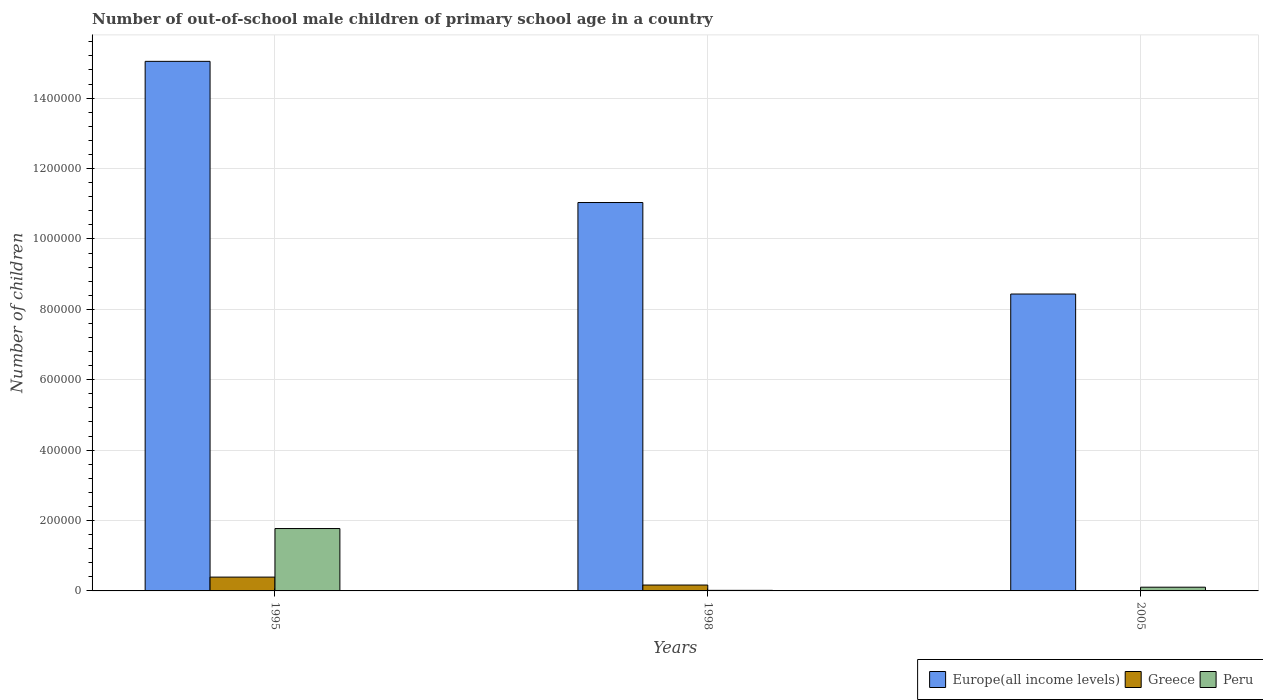How many groups of bars are there?
Give a very brief answer. 3. Are the number of bars per tick equal to the number of legend labels?
Your answer should be very brief. Yes. What is the label of the 2nd group of bars from the left?
Provide a short and direct response. 1998. In how many cases, is the number of bars for a given year not equal to the number of legend labels?
Your answer should be compact. 0. What is the number of out-of-school male children in Europe(all income levels) in 1995?
Make the answer very short. 1.50e+06. Across all years, what is the maximum number of out-of-school male children in Peru?
Keep it short and to the point. 1.77e+05. Across all years, what is the minimum number of out-of-school male children in Europe(all income levels)?
Give a very brief answer. 8.43e+05. What is the total number of out-of-school male children in Europe(all income levels) in the graph?
Your response must be concise. 3.45e+06. What is the difference between the number of out-of-school male children in Peru in 1998 and that in 2005?
Give a very brief answer. -8945. What is the difference between the number of out-of-school male children in Greece in 1998 and the number of out-of-school male children in Europe(all income levels) in 1995?
Ensure brevity in your answer.  -1.49e+06. What is the average number of out-of-school male children in Greece per year?
Keep it short and to the point. 1.87e+04. In the year 1998, what is the difference between the number of out-of-school male children in Peru and number of out-of-school male children in Europe(all income levels)?
Offer a very short reply. -1.10e+06. What is the ratio of the number of out-of-school male children in Peru in 1998 to that in 2005?
Keep it short and to the point. 0.15. What is the difference between the highest and the second highest number of out-of-school male children in Greece?
Provide a short and direct response. 2.25e+04. What is the difference between the highest and the lowest number of out-of-school male children in Greece?
Your answer should be very brief. 3.90e+04. Is the sum of the number of out-of-school male children in Europe(all income levels) in 1995 and 2005 greater than the maximum number of out-of-school male children in Greece across all years?
Provide a succinct answer. Yes. What does the 2nd bar from the left in 1998 represents?
Keep it short and to the point. Greece. What does the 1st bar from the right in 2005 represents?
Your answer should be compact. Peru. How many bars are there?
Your response must be concise. 9. Are the values on the major ticks of Y-axis written in scientific E-notation?
Offer a terse response. No. How many legend labels are there?
Your answer should be very brief. 3. How are the legend labels stacked?
Your response must be concise. Horizontal. What is the title of the graph?
Your answer should be compact. Number of out-of-school male children of primary school age in a country. What is the label or title of the X-axis?
Offer a very short reply. Years. What is the label or title of the Y-axis?
Provide a short and direct response. Number of children. What is the Number of children of Europe(all income levels) in 1995?
Ensure brevity in your answer.  1.50e+06. What is the Number of children of Greece in 1995?
Make the answer very short. 3.92e+04. What is the Number of children in Peru in 1995?
Provide a short and direct response. 1.77e+05. What is the Number of children of Europe(all income levels) in 1998?
Offer a very short reply. 1.10e+06. What is the Number of children in Greece in 1998?
Offer a terse response. 1.67e+04. What is the Number of children in Peru in 1998?
Offer a very short reply. 1620. What is the Number of children in Europe(all income levels) in 2005?
Your answer should be very brief. 8.43e+05. What is the Number of children in Greece in 2005?
Your answer should be compact. 241. What is the Number of children of Peru in 2005?
Your answer should be compact. 1.06e+04. Across all years, what is the maximum Number of children in Europe(all income levels)?
Your response must be concise. 1.50e+06. Across all years, what is the maximum Number of children of Greece?
Provide a succinct answer. 3.92e+04. Across all years, what is the maximum Number of children of Peru?
Offer a very short reply. 1.77e+05. Across all years, what is the minimum Number of children of Europe(all income levels)?
Keep it short and to the point. 8.43e+05. Across all years, what is the minimum Number of children of Greece?
Your answer should be very brief. 241. Across all years, what is the minimum Number of children in Peru?
Offer a very short reply. 1620. What is the total Number of children of Europe(all income levels) in the graph?
Your answer should be compact. 3.45e+06. What is the total Number of children of Greece in the graph?
Your answer should be very brief. 5.62e+04. What is the total Number of children of Peru in the graph?
Offer a terse response. 1.89e+05. What is the difference between the Number of children of Europe(all income levels) in 1995 and that in 1998?
Offer a very short reply. 4.01e+05. What is the difference between the Number of children in Greece in 1995 and that in 1998?
Offer a terse response. 2.25e+04. What is the difference between the Number of children in Peru in 1995 and that in 1998?
Your answer should be very brief. 1.76e+05. What is the difference between the Number of children of Europe(all income levels) in 1995 and that in 2005?
Keep it short and to the point. 6.61e+05. What is the difference between the Number of children in Greece in 1995 and that in 2005?
Your answer should be very brief. 3.90e+04. What is the difference between the Number of children of Peru in 1995 and that in 2005?
Make the answer very short. 1.67e+05. What is the difference between the Number of children of Europe(all income levels) in 1998 and that in 2005?
Your answer should be very brief. 2.60e+05. What is the difference between the Number of children of Greece in 1998 and that in 2005?
Ensure brevity in your answer.  1.65e+04. What is the difference between the Number of children in Peru in 1998 and that in 2005?
Offer a very short reply. -8945. What is the difference between the Number of children in Europe(all income levels) in 1995 and the Number of children in Greece in 1998?
Provide a succinct answer. 1.49e+06. What is the difference between the Number of children of Europe(all income levels) in 1995 and the Number of children of Peru in 1998?
Your answer should be very brief. 1.50e+06. What is the difference between the Number of children of Greece in 1995 and the Number of children of Peru in 1998?
Your answer should be very brief. 3.76e+04. What is the difference between the Number of children in Europe(all income levels) in 1995 and the Number of children in Greece in 2005?
Provide a succinct answer. 1.50e+06. What is the difference between the Number of children of Europe(all income levels) in 1995 and the Number of children of Peru in 2005?
Ensure brevity in your answer.  1.49e+06. What is the difference between the Number of children of Greece in 1995 and the Number of children of Peru in 2005?
Give a very brief answer. 2.87e+04. What is the difference between the Number of children of Europe(all income levels) in 1998 and the Number of children of Greece in 2005?
Provide a succinct answer. 1.10e+06. What is the difference between the Number of children in Europe(all income levels) in 1998 and the Number of children in Peru in 2005?
Your response must be concise. 1.09e+06. What is the difference between the Number of children in Greece in 1998 and the Number of children in Peru in 2005?
Offer a very short reply. 6163. What is the average Number of children of Europe(all income levels) per year?
Offer a terse response. 1.15e+06. What is the average Number of children of Greece per year?
Your answer should be compact. 1.87e+04. What is the average Number of children in Peru per year?
Provide a short and direct response. 6.31e+04. In the year 1995, what is the difference between the Number of children in Europe(all income levels) and Number of children in Greece?
Give a very brief answer. 1.47e+06. In the year 1995, what is the difference between the Number of children in Europe(all income levels) and Number of children in Peru?
Ensure brevity in your answer.  1.33e+06. In the year 1995, what is the difference between the Number of children of Greece and Number of children of Peru?
Provide a succinct answer. -1.38e+05. In the year 1998, what is the difference between the Number of children of Europe(all income levels) and Number of children of Greece?
Your answer should be compact. 1.09e+06. In the year 1998, what is the difference between the Number of children of Europe(all income levels) and Number of children of Peru?
Offer a terse response. 1.10e+06. In the year 1998, what is the difference between the Number of children of Greece and Number of children of Peru?
Offer a terse response. 1.51e+04. In the year 2005, what is the difference between the Number of children of Europe(all income levels) and Number of children of Greece?
Make the answer very short. 8.43e+05. In the year 2005, what is the difference between the Number of children in Europe(all income levels) and Number of children in Peru?
Ensure brevity in your answer.  8.33e+05. In the year 2005, what is the difference between the Number of children in Greece and Number of children in Peru?
Provide a succinct answer. -1.03e+04. What is the ratio of the Number of children in Europe(all income levels) in 1995 to that in 1998?
Provide a short and direct response. 1.36. What is the ratio of the Number of children of Greece in 1995 to that in 1998?
Your answer should be very brief. 2.35. What is the ratio of the Number of children in Peru in 1995 to that in 1998?
Offer a terse response. 109.39. What is the ratio of the Number of children of Europe(all income levels) in 1995 to that in 2005?
Give a very brief answer. 1.78. What is the ratio of the Number of children in Greece in 1995 to that in 2005?
Provide a succinct answer. 162.85. What is the ratio of the Number of children in Peru in 1995 to that in 2005?
Make the answer very short. 16.77. What is the ratio of the Number of children in Europe(all income levels) in 1998 to that in 2005?
Your response must be concise. 1.31. What is the ratio of the Number of children of Greece in 1998 to that in 2005?
Give a very brief answer. 69.41. What is the ratio of the Number of children in Peru in 1998 to that in 2005?
Keep it short and to the point. 0.15. What is the difference between the highest and the second highest Number of children of Europe(all income levels)?
Make the answer very short. 4.01e+05. What is the difference between the highest and the second highest Number of children in Greece?
Your response must be concise. 2.25e+04. What is the difference between the highest and the second highest Number of children of Peru?
Make the answer very short. 1.67e+05. What is the difference between the highest and the lowest Number of children of Europe(all income levels)?
Your answer should be very brief. 6.61e+05. What is the difference between the highest and the lowest Number of children of Greece?
Your answer should be very brief. 3.90e+04. What is the difference between the highest and the lowest Number of children of Peru?
Provide a short and direct response. 1.76e+05. 